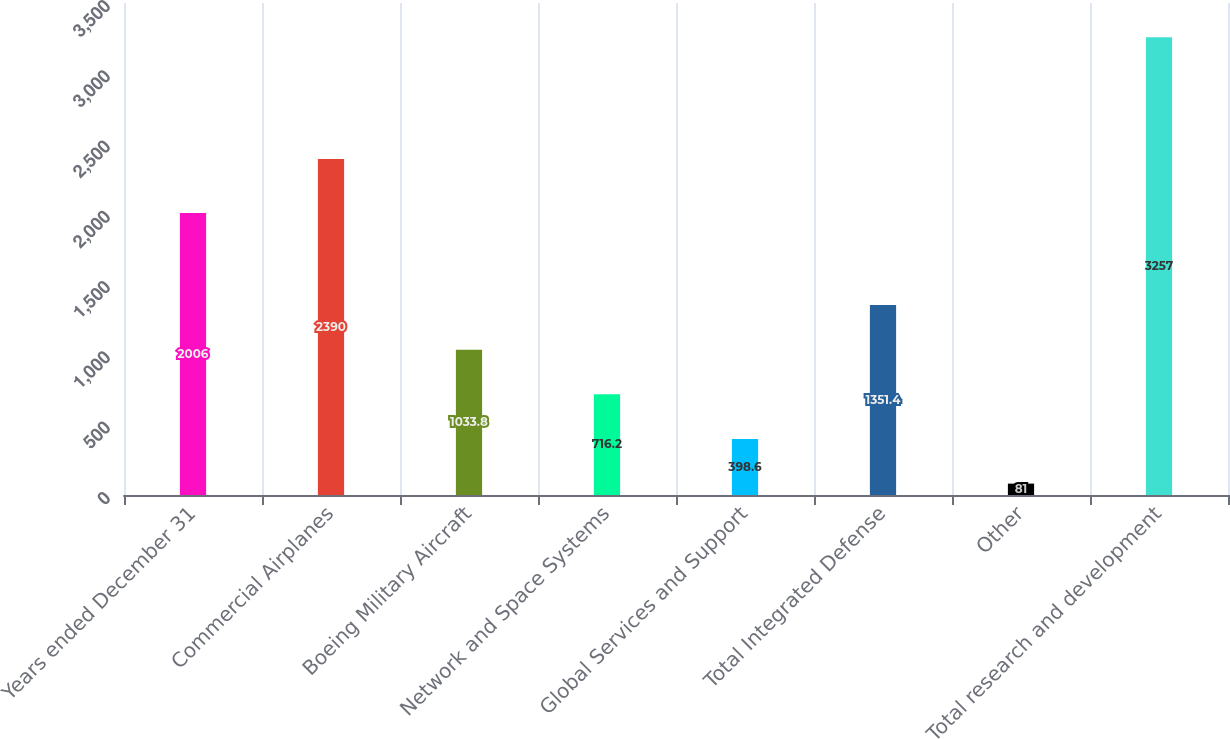Convert chart. <chart><loc_0><loc_0><loc_500><loc_500><bar_chart><fcel>Years ended December 31<fcel>Commercial Airplanes<fcel>Boeing Military Aircraft<fcel>Network and Space Systems<fcel>Global Services and Support<fcel>Total Integrated Defense<fcel>Other<fcel>Total research and development<nl><fcel>2006<fcel>2390<fcel>1033.8<fcel>716.2<fcel>398.6<fcel>1351.4<fcel>81<fcel>3257<nl></chart> 